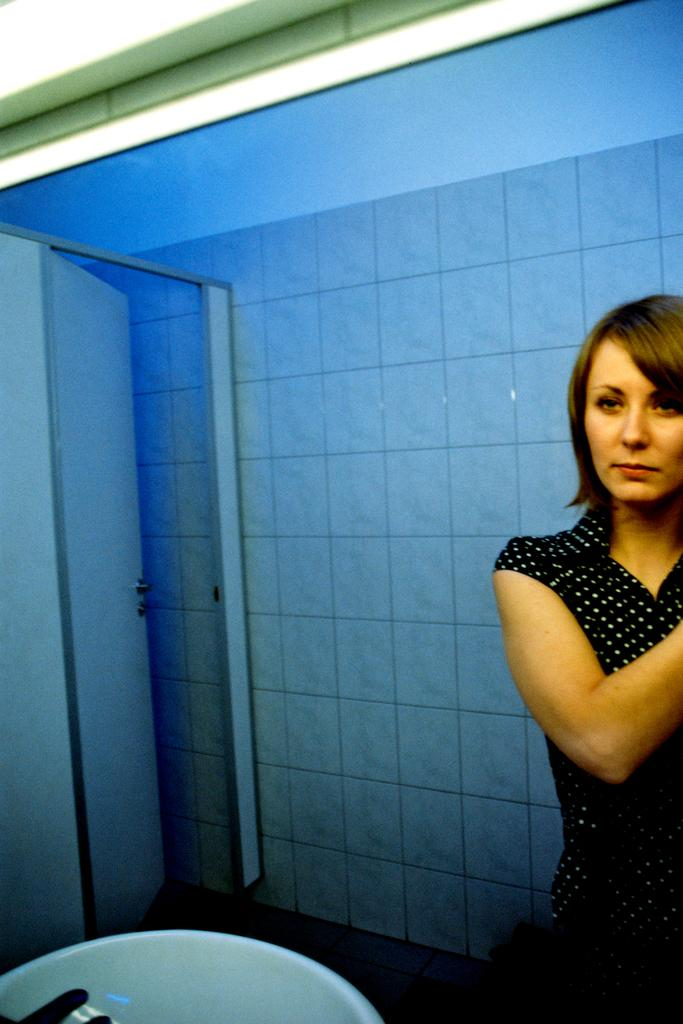What can be seen in the mirror in the image? There is a woman in the image, as seen in the mirror. What is located near the mirror in the image? There is a sink in the image. What architectural feature is present in the image? There is a door in the image. What is visible in the background of the image? There is a wall in the background of the image. What color is the tray on the wall in the image? There is no tray present on the wall in the image. 